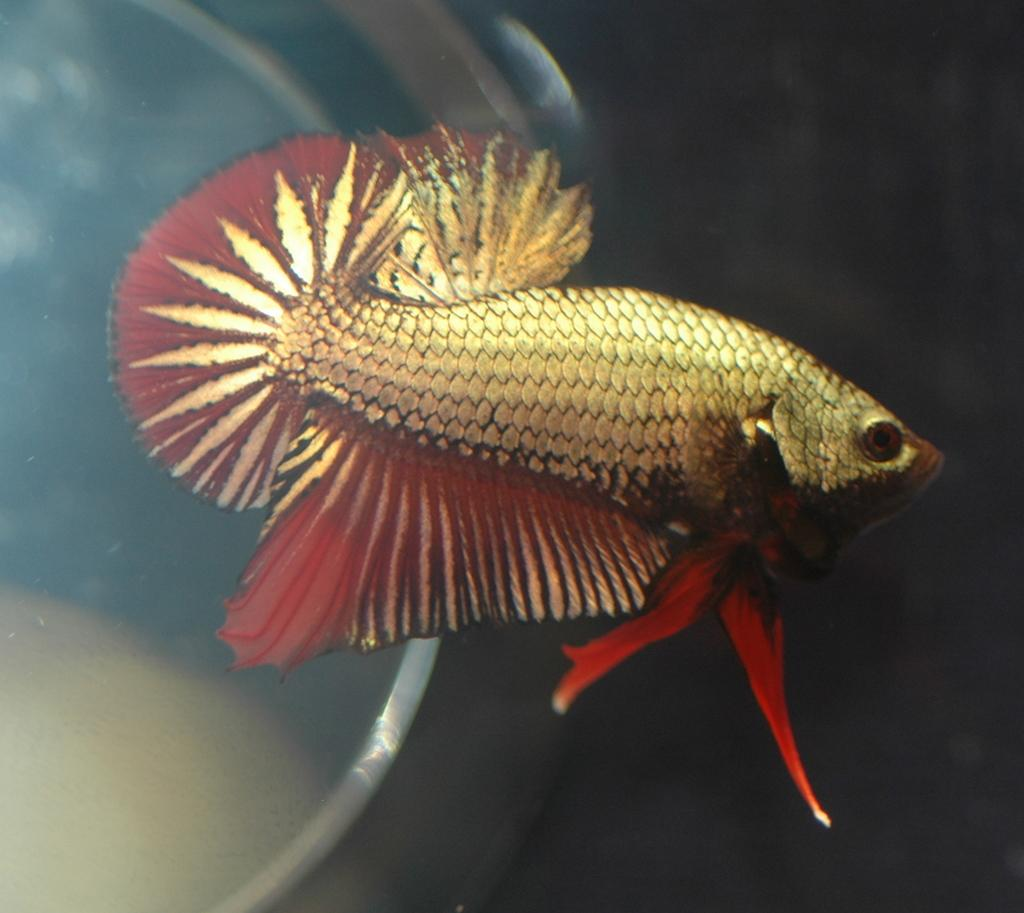What type of animal is present in the image? There is a fish in the image. What is the primary object in the image? The image appears to be of a glass bowl. Can you see a goose swimming with the fish in the image? There is no goose present in the image; it only features a fish in a glass bowl. How many bridges can be seen crossing over the fish in the image? There are no bridges present in the image. 